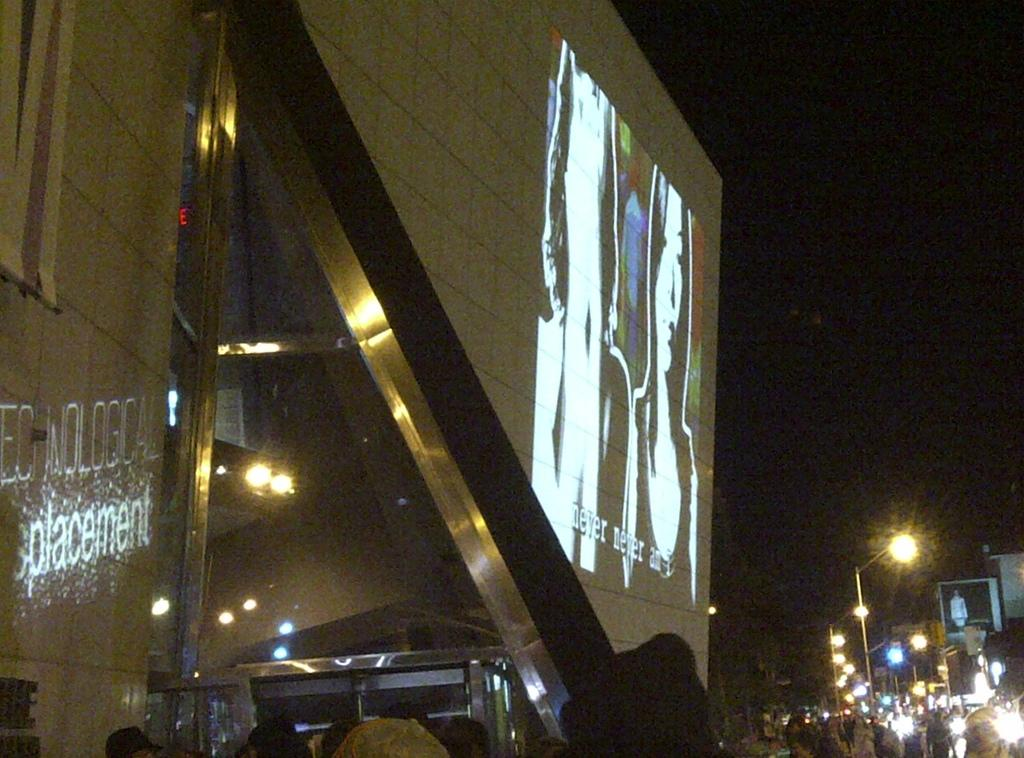What is present on the wall in the image? There is a screen on the wall in the image. What else can be seen on the wall or attached to it? There are no other objects visible on the wall in the image. What type of lighting is present in the image? There are lights on poles in the image. How would you describe the overall lighting in the image? The background of the image appears to be dark. Can you see any birds acting out an agreement in the image? There are no birds or any indication of an agreement in the image. 